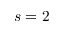<formula> <loc_0><loc_0><loc_500><loc_500>s = 2</formula> 